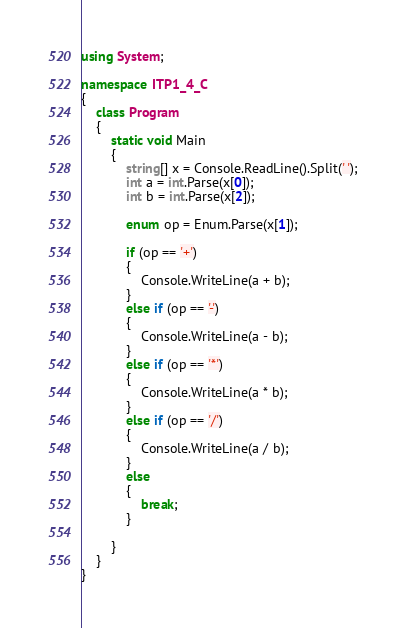Convert code to text. <code><loc_0><loc_0><loc_500><loc_500><_C#_>using System;

namespace ITP1_4_C
{
    class Program
    {
        static void Main
        {
            string[] x = Console.ReadLine().Split(' ');
            int a = int.Parse(x[0]);
            int b = int.Parse(x[2]);
            
            enum op = Enum.Parse(x[1]);
                
            if (op == '+') 
            {
                Console.WriteLine(a + b);
            }
            else if (op == '-')
            {
                Console.WriteLine(a - b);
            }
            else if (op == '*')
            {
                Console.WriteLine(a * b);
            }
            else if (op == '/')
            {
                Console.WriteLine(a / b);
            }
            else 
            {
                break;
            }
            
        }
    }
}
</code> 